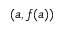<formula> <loc_0><loc_0><loc_500><loc_500>\left ( a , f ( a ) \right )</formula> 